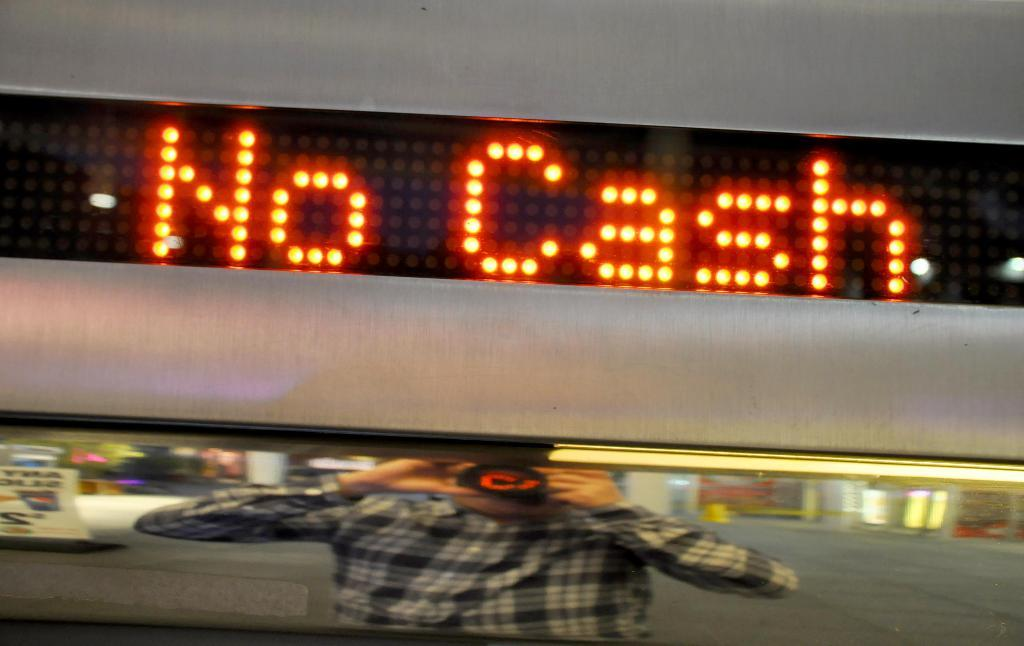<image>
Summarize the visual content of the image. the word cash that is above a person taking a photo 